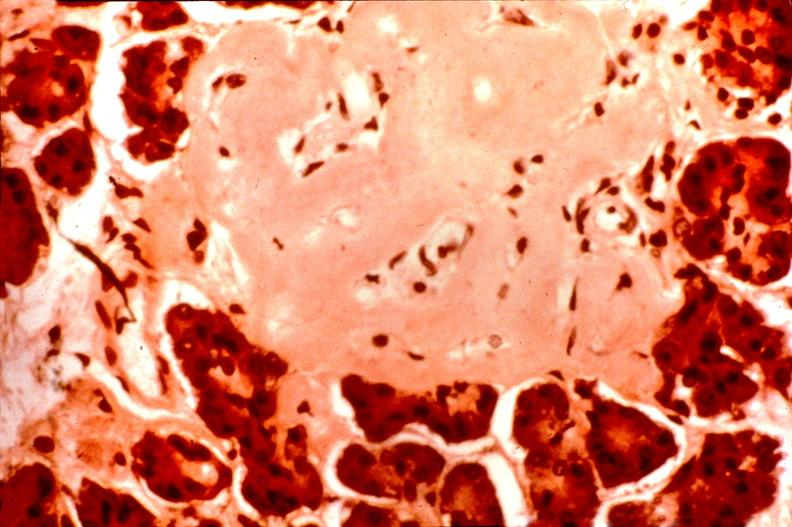where is this part in the figure?
Answer the question using a single word or phrase. Endocrine system 